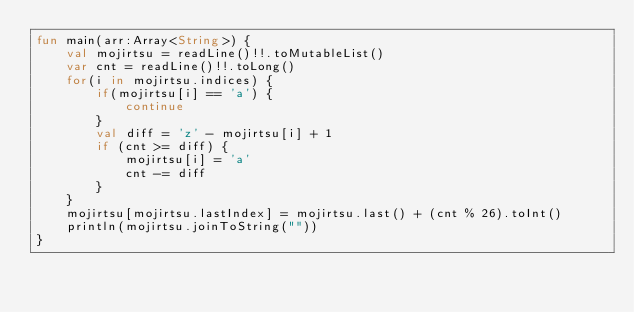<code> <loc_0><loc_0><loc_500><loc_500><_Kotlin_>fun main(arr:Array<String>) {
    val mojirtsu = readLine()!!.toMutableList()
    var cnt = readLine()!!.toLong()
    for(i in mojirtsu.indices) {
        if(mojirtsu[i] == 'a') {
            continue
        }
        val diff = 'z' - mojirtsu[i] + 1
        if (cnt >= diff) {
            mojirtsu[i] = 'a'
            cnt -= diff
        }
    }
    mojirtsu[mojirtsu.lastIndex] = mojirtsu.last() + (cnt % 26).toInt()
    println(mojirtsu.joinToString(""))
}
</code> 